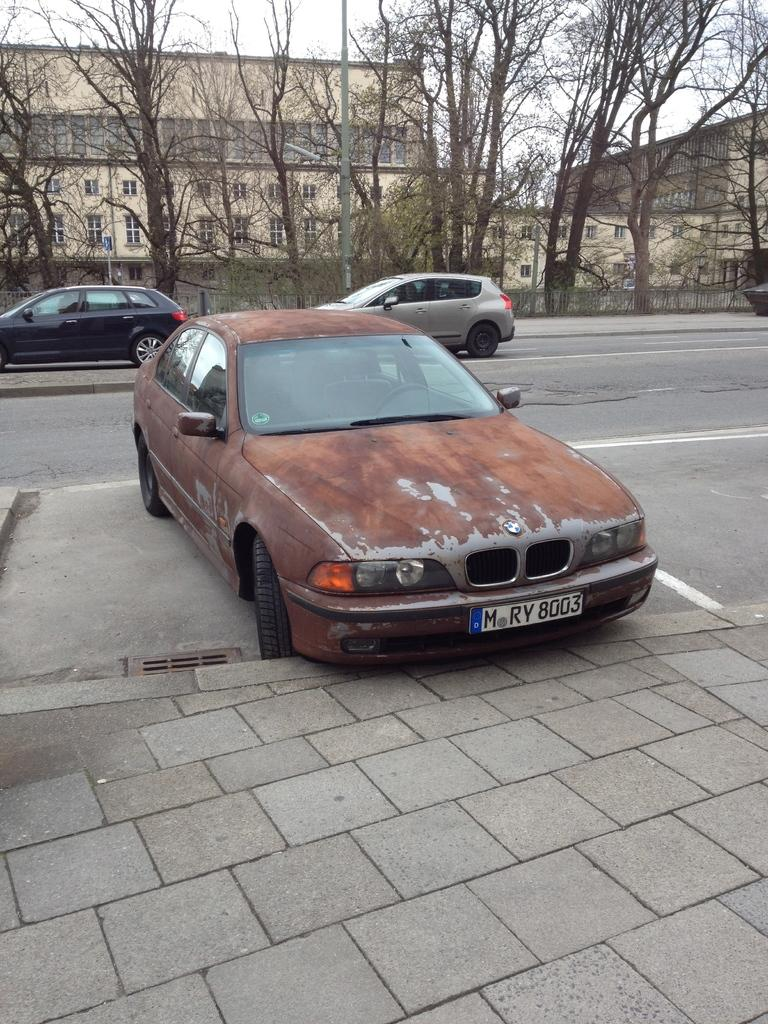What type of vehicles can be seen in the image? There are cars in the image. What other objects or structures are present in the image? There are trees and buildings in the image. What part of the natural environment is visible in the image? The sky is visible in the image. Where is the camera located in the image? There is no camera present in the image; it is a photograph taken by a camera. Can you see a giraffe in the image? No, there is no giraffe present in the image. 